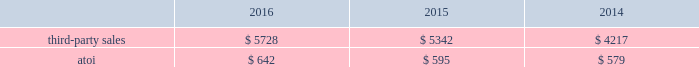December 31 , 2018 .
Alcoa corporation will supply all required raw materials to arconic and arconic will process the raw materials into finished can sheet coils ready for shipment to the end customer .
Tolling revenue for the two months ended december 31 , 2016 was approximately $ 37 million .
In 2017 , demand in the automotive end market is expected to continue to grow due to the growing demand for innovative products and aluminum-intensive vehicles .
Demand from the commercial airframe end market is expected to be flat in 2017 as the ramp up of new programs is offset by customer destocking and lower build rates for aluminum intensive wide-body programs .
Sales to the packaging market are expected to decline due to continuing pricing pressure within this market and the ramp-down of the north american packaging operations .
Net productivity improvements are anticipated to continue .
Engineered products and solutions .
The engineered products and solutions segment produces products that are used primarily in the aerospace ( commercial and defense ) , commercial transportation , and power generation end markets .
Such products include fastening systems ( titanium , steel , and nickel superalloys ) and seamless rolled rings ( mostly nickel superalloys ) ; investment castings ( nickel superalloys , titanium , and aluminum ) , including airfoils and forged jet engine components ( e.g. , jet engine disks ) , and extruded , machined and formed aircraft parts ( titanium and aluminum ) , all of which are sold directly to customers and through distributors .
More than 75% ( 75 % ) of the third-party sales in this segment are from the aerospace end market .
A small part of this segment also produces various forged , extruded , and machined metal products ( titanium , aluminum and steel ) for the oil and gas , industrial products , automotive , and land and sea defense end markets .
Seasonal decreases in sales are generally experienced in the third quarter of the year due to the european summer slowdown across all end markets .
Generally , the sales and costs and expenses of this segment are transacted in the local currency of the respective operations , which are mostly the u.s .
Dollar , british pound and the euro .
In july 2015 , arconic completed the acquisition of rti , a global supplier of titanium and specialty metal products and services for the commercial aerospace , defense , energy , and medical device end markets .
The purpose of the acquisition was to expand arconic 2019s range of titanium offerings and add advanced technologies and materials , primarily related to the aerospace end market .
In 2014 , rti generated net sales of $ 794 and had approximately 2600 employees .
The operating results and assets and liabilities of rti have been included within the engineered products and solutions segment since the date of acquisition .
In march 2015 , arconic completed the acquisition of tital , a privately held aerospace castings company with approximately 650 employees based in germany .
Tital produces aluminum and titanium investment casting products for the aerospace and defense end markets .
In 2014 , tital generated sales of approximately $ 100 .
The purpose of the acquisition was to capture increasing demand for advanced jet engine components made of titanium , establish titanium- casting capabilities in europe , and expand existing aluminum casting capacity .
The operating results and assets and liabilities of tital have been included within the engineered products and solutions segment since the date of acquisition .
In november 2014 , arconic completed the acquisition of firth rixson , a global leader in aerospace jet engine components .
Firth rixson manufactures rings , forgings , and metal products for the aerospace end market , as well as other markets requiring highly-engineered material applications .
The purpose of the acquisition was to strengthen arconic 2019s aerospace business and position the company to capture additional aerospace growth with a broader range of high-growth , value-add jet engine components .
Firth rixson generated sales of approximately $ 970 in 2014 and had 13 operating facilities in the united states , united kingdom , europe , and asia employing approximately 2400 people combined .
The operating results and assets and liabilities of firth rixson have been included within the engineered products and solutions segment since the date of acquisition. .
What is the total amount of dollars received from aerospace end market sales in 2015? 
Rationale: it is the total third-party sales multiplied by its percentage of aerospace end market sales .
Computations: (5342 * 75%)
Answer: 4006.5. 